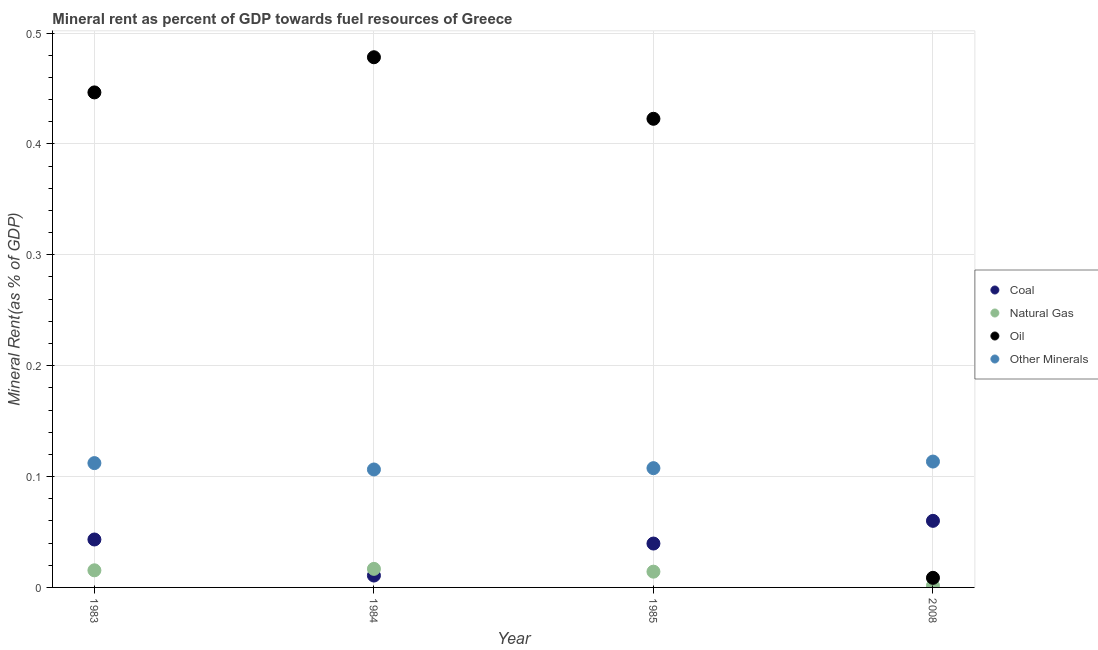What is the  rent of other minerals in 1984?
Provide a short and direct response. 0.11. Across all years, what is the maximum coal rent?
Your response must be concise. 0.06. Across all years, what is the minimum  rent of other minerals?
Offer a terse response. 0.11. In which year was the coal rent minimum?
Offer a terse response. 1984. What is the total oil rent in the graph?
Your answer should be compact. 1.36. What is the difference between the coal rent in 1983 and that in 2008?
Your answer should be compact. -0.02. What is the difference between the  rent of other minerals in 1985 and the natural gas rent in 2008?
Provide a succinct answer. 0.11. What is the average  rent of other minerals per year?
Provide a short and direct response. 0.11. In the year 1985, what is the difference between the oil rent and natural gas rent?
Offer a very short reply. 0.41. In how many years, is the coal rent greater than 0.34 %?
Ensure brevity in your answer.  0. What is the ratio of the  rent of other minerals in 1984 to that in 2008?
Your response must be concise. 0.94. Is the difference between the natural gas rent in 1983 and 2008 greater than the difference between the  rent of other minerals in 1983 and 2008?
Your response must be concise. Yes. What is the difference between the highest and the second highest coal rent?
Keep it short and to the point. 0.02. What is the difference between the highest and the lowest natural gas rent?
Ensure brevity in your answer.  0.02. Is the sum of the natural gas rent in 1984 and 2008 greater than the maximum coal rent across all years?
Give a very brief answer. No. Is it the case that in every year, the sum of the natural gas rent and oil rent is greater than the sum of coal rent and  rent of other minerals?
Your response must be concise. No. Does the natural gas rent monotonically increase over the years?
Your answer should be very brief. No. Is the oil rent strictly greater than the  rent of other minerals over the years?
Offer a terse response. No. Is the natural gas rent strictly less than the coal rent over the years?
Provide a succinct answer. No. How many dotlines are there?
Keep it short and to the point. 4. How many years are there in the graph?
Give a very brief answer. 4. What is the difference between two consecutive major ticks on the Y-axis?
Provide a short and direct response. 0.1. Where does the legend appear in the graph?
Offer a very short reply. Center right. What is the title of the graph?
Your response must be concise. Mineral rent as percent of GDP towards fuel resources of Greece. What is the label or title of the Y-axis?
Provide a short and direct response. Mineral Rent(as % of GDP). What is the Mineral Rent(as % of GDP) in Coal in 1983?
Keep it short and to the point. 0.04. What is the Mineral Rent(as % of GDP) of Natural Gas in 1983?
Your response must be concise. 0.02. What is the Mineral Rent(as % of GDP) in Oil in 1983?
Keep it short and to the point. 0.45. What is the Mineral Rent(as % of GDP) of Other Minerals in 1983?
Ensure brevity in your answer.  0.11. What is the Mineral Rent(as % of GDP) of Coal in 1984?
Ensure brevity in your answer.  0.01. What is the Mineral Rent(as % of GDP) in Natural Gas in 1984?
Your answer should be compact. 0.02. What is the Mineral Rent(as % of GDP) in Oil in 1984?
Provide a short and direct response. 0.48. What is the Mineral Rent(as % of GDP) of Other Minerals in 1984?
Provide a succinct answer. 0.11. What is the Mineral Rent(as % of GDP) of Coal in 1985?
Keep it short and to the point. 0.04. What is the Mineral Rent(as % of GDP) in Natural Gas in 1985?
Make the answer very short. 0.01. What is the Mineral Rent(as % of GDP) in Oil in 1985?
Make the answer very short. 0.42. What is the Mineral Rent(as % of GDP) of Other Minerals in 1985?
Your answer should be very brief. 0.11. What is the Mineral Rent(as % of GDP) of Coal in 2008?
Offer a very short reply. 0.06. What is the Mineral Rent(as % of GDP) in Natural Gas in 2008?
Your answer should be very brief. 0. What is the Mineral Rent(as % of GDP) of Oil in 2008?
Ensure brevity in your answer.  0.01. What is the Mineral Rent(as % of GDP) in Other Minerals in 2008?
Keep it short and to the point. 0.11. Across all years, what is the maximum Mineral Rent(as % of GDP) in Coal?
Offer a terse response. 0.06. Across all years, what is the maximum Mineral Rent(as % of GDP) of Natural Gas?
Offer a terse response. 0.02. Across all years, what is the maximum Mineral Rent(as % of GDP) of Oil?
Your response must be concise. 0.48. Across all years, what is the maximum Mineral Rent(as % of GDP) in Other Minerals?
Ensure brevity in your answer.  0.11. Across all years, what is the minimum Mineral Rent(as % of GDP) in Coal?
Your response must be concise. 0.01. Across all years, what is the minimum Mineral Rent(as % of GDP) of Natural Gas?
Provide a succinct answer. 0. Across all years, what is the minimum Mineral Rent(as % of GDP) in Oil?
Your response must be concise. 0.01. Across all years, what is the minimum Mineral Rent(as % of GDP) of Other Minerals?
Offer a terse response. 0.11. What is the total Mineral Rent(as % of GDP) in Coal in the graph?
Offer a terse response. 0.15. What is the total Mineral Rent(as % of GDP) of Natural Gas in the graph?
Offer a terse response. 0.05. What is the total Mineral Rent(as % of GDP) in Oil in the graph?
Offer a terse response. 1.36. What is the total Mineral Rent(as % of GDP) in Other Minerals in the graph?
Ensure brevity in your answer.  0.44. What is the difference between the Mineral Rent(as % of GDP) of Coal in 1983 and that in 1984?
Your answer should be very brief. 0.03. What is the difference between the Mineral Rent(as % of GDP) in Natural Gas in 1983 and that in 1984?
Your answer should be very brief. -0. What is the difference between the Mineral Rent(as % of GDP) in Oil in 1983 and that in 1984?
Provide a short and direct response. -0.03. What is the difference between the Mineral Rent(as % of GDP) in Other Minerals in 1983 and that in 1984?
Your answer should be very brief. 0.01. What is the difference between the Mineral Rent(as % of GDP) in Coal in 1983 and that in 1985?
Your response must be concise. 0. What is the difference between the Mineral Rent(as % of GDP) of Natural Gas in 1983 and that in 1985?
Your answer should be compact. 0. What is the difference between the Mineral Rent(as % of GDP) in Oil in 1983 and that in 1985?
Provide a succinct answer. 0.02. What is the difference between the Mineral Rent(as % of GDP) of Other Minerals in 1983 and that in 1985?
Your response must be concise. 0. What is the difference between the Mineral Rent(as % of GDP) of Coal in 1983 and that in 2008?
Your response must be concise. -0.02. What is the difference between the Mineral Rent(as % of GDP) of Natural Gas in 1983 and that in 2008?
Give a very brief answer. 0.01. What is the difference between the Mineral Rent(as % of GDP) of Oil in 1983 and that in 2008?
Your response must be concise. 0.44. What is the difference between the Mineral Rent(as % of GDP) of Other Minerals in 1983 and that in 2008?
Give a very brief answer. -0. What is the difference between the Mineral Rent(as % of GDP) in Coal in 1984 and that in 1985?
Provide a succinct answer. -0.03. What is the difference between the Mineral Rent(as % of GDP) in Natural Gas in 1984 and that in 1985?
Offer a very short reply. 0. What is the difference between the Mineral Rent(as % of GDP) of Oil in 1984 and that in 1985?
Your response must be concise. 0.06. What is the difference between the Mineral Rent(as % of GDP) in Other Minerals in 1984 and that in 1985?
Offer a terse response. -0. What is the difference between the Mineral Rent(as % of GDP) of Coal in 1984 and that in 2008?
Offer a terse response. -0.05. What is the difference between the Mineral Rent(as % of GDP) in Natural Gas in 1984 and that in 2008?
Offer a very short reply. 0.02. What is the difference between the Mineral Rent(as % of GDP) of Oil in 1984 and that in 2008?
Your response must be concise. 0.47. What is the difference between the Mineral Rent(as % of GDP) in Other Minerals in 1984 and that in 2008?
Your answer should be compact. -0.01. What is the difference between the Mineral Rent(as % of GDP) of Coal in 1985 and that in 2008?
Make the answer very short. -0.02. What is the difference between the Mineral Rent(as % of GDP) of Natural Gas in 1985 and that in 2008?
Provide a succinct answer. 0.01. What is the difference between the Mineral Rent(as % of GDP) of Oil in 1985 and that in 2008?
Your response must be concise. 0.41. What is the difference between the Mineral Rent(as % of GDP) of Other Minerals in 1985 and that in 2008?
Your answer should be compact. -0.01. What is the difference between the Mineral Rent(as % of GDP) in Coal in 1983 and the Mineral Rent(as % of GDP) in Natural Gas in 1984?
Offer a terse response. 0.03. What is the difference between the Mineral Rent(as % of GDP) of Coal in 1983 and the Mineral Rent(as % of GDP) of Oil in 1984?
Your answer should be compact. -0.43. What is the difference between the Mineral Rent(as % of GDP) of Coal in 1983 and the Mineral Rent(as % of GDP) of Other Minerals in 1984?
Your answer should be compact. -0.06. What is the difference between the Mineral Rent(as % of GDP) in Natural Gas in 1983 and the Mineral Rent(as % of GDP) in Oil in 1984?
Ensure brevity in your answer.  -0.46. What is the difference between the Mineral Rent(as % of GDP) in Natural Gas in 1983 and the Mineral Rent(as % of GDP) in Other Minerals in 1984?
Your answer should be compact. -0.09. What is the difference between the Mineral Rent(as % of GDP) in Oil in 1983 and the Mineral Rent(as % of GDP) in Other Minerals in 1984?
Your answer should be compact. 0.34. What is the difference between the Mineral Rent(as % of GDP) in Coal in 1983 and the Mineral Rent(as % of GDP) in Natural Gas in 1985?
Give a very brief answer. 0.03. What is the difference between the Mineral Rent(as % of GDP) of Coal in 1983 and the Mineral Rent(as % of GDP) of Oil in 1985?
Provide a short and direct response. -0.38. What is the difference between the Mineral Rent(as % of GDP) in Coal in 1983 and the Mineral Rent(as % of GDP) in Other Minerals in 1985?
Ensure brevity in your answer.  -0.06. What is the difference between the Mineral Rent(as % of GDP) of Natural Gas in 1983 and the Mineral Rent(as % of GDP) of Oil in 1985?
Offer a terse response. -0.41. What is the difference between the Mineral Rent(as % of GDP) in Natural Gas in 1983 and the Mineral Rent(as % of GDP) in Other Minerals in 1985?
Your answer should be very brief. -0.09. What is the difference between the Mineral Rent(as % of GDP) in Oil in 1983 and the Mineral Rent(as % of GDP) in Other Minerals in 1985?
Give a very brief answer. 0.34. What is the difference between the Mineral Rent(as % of GDP) of Coal in 1983 and the Mineral Rent(as % of GDP) of Natural Gas in 2008?
Provide a short and direct response. 0.04. What is the difference between the Mineral Rent(as % of GDP) of Coal in 1983 and the Mineral Rent(as % of GDP) of Oil in 2008?
Your response must be concise. 0.03. What is the difference between the Mineral Rent(as % of GDP) in Coal in 1983 and the Mineral Rent(as % of GDP) in Other Minerals in 2008?
Your answer should be compact. -0.07. What is the difference between the Mineral Rent(as % of GDP) in Natural Gas in 1983 and the Mineral Rent(as % of GDP) in Oil in 2008?
Make the answer very short. 0.01. What is the difference between the Mineral Rent(as % of GDP) of Natural Gas in 1983 and the Mineral Rent(as % of GDP) of Other Minerals in 2008?
Keep it short and to the point. -0.1. What is the difference between the Mineral Rent(as % of GDP) in Oil in 1983 and the Mineral Rent(as % of GDP) in Other Minerals in 2008?
Offer a terse response. 0.33. What is the difference between the Mineral Rent(as % of GDP) of Coal in 1984 and the Mineral Rent(as % of GDP) of Natural Gas in 1985?
Keep it short and to the point. -0. What is the difference between the Mineral Rent(as % of GDP) of Coal in 1984 and the Mineral Rent(as % of GDP) of Oil in 1985?
Ensure brevity in your answer.  -0.41. What is the difference between the Mineral Rent(as % of GDP) of Coal in 1984 and the Mineral Rent(as % of GDP) of Other Minerals in 1985?
Provide a succinct answer. -0.1. What is the difference between the Mineral Rent(as % of GDP) of Natural Gas in 1984 and the Mineral Rent(as % of GDP) of Oil in 1985?
Offer a very short reply. -0.41. What is the difference between the Mineral Rent(as % of GDP) of Natural Gas in 1984 and the Mineral Rent(as % of GDP) of Other Minerals in 1985?
Offer a terse response. -0.09. What is the difference between the Mineral Rent(as % of GDP) in Oil in 1984 and the Mineral Rent(as % of GDP) in Other Minerals in 1985?
Keep it short and to the point. 0.37. What is the difference between the Mineral Rent(as % of GDP) in Coal in 1984 and the Mineral Rent(as % of GDP) in Natural Gas in 2008?
Keep it short and to the point. 0.01. What is the difference between the Mineral Rent(as % of GDP) of Coal in 1984 and the Mineral Rent(as % of GDP) of Oil in 2008?
Provide a short and direct response. 0. What is the difference between the Mineral Rent(as % of GDP) in Coal in 1984 and the Mineral Rent(as % of GDP) in Other Minerals in 2008?
Offer a very short reply. -0.1. What is the difference between the Mineral Rent(as % of GDP) in Natural Gas in 1984 and the Mineral Rent(as % of GDP) in Oil in 2008?
Offer a terse response. 0.01. What is the difference between the Mineral Rent(as % of GDP) of Natural Gas in 1984 and the Mineral Rent(as % of GDP) of Other Minerals in 2008?
Give a very brief answer. -0.1. What is the difference between the Mineral Rent(as % of GDP) in Oil in 1984 and the Mineral Rent(as % of GDP) in Other Minerals in 2008?
Offer a very short reply. 0.36. What is the difference between the Mineral Rent(as % of GDP) in Coal in 1985 and the Mineral Rent(as % of GDP) in Natural Gas in 2008?
Keep it short and to the point. 0.04. What is the difference between the Mineral Rent(as % of GDP) of Coal in 1985 and the Mineral Rent(as % of GDP) of Oil in 2008?
Make the answer very short. 0.03. What is the difference between the Mineral Rent(as % of GDP) in Coal in 1985 and the Mineral Rent(as % of GDP) in Other Minerals in 2008?
Your response must be concise. -0.07. What is the difference between the Mineral Rent(as % of GDP) in Natural Gas in 1985 and the Mineral Rent(as % of GDP) in Oil in 2008?
Ensure brevity in your answer.  0.01. What is the difference between the Mineral Rent(as % of GDP) of Natural Gas in 1985 and the Mineral Rent(as % of GDP) of Other Minerals in 2008?
Provide a short and direct response. -0.1. What is the difference between the Mineral Rent(as % of GDP) of Oil in 1985 and the Mineral Rent(as % of GDP) of Other Minerals in 2008?
Offer a very short reply. 0.31. What is the average Mineral Rent(as % of GDP) in Coal per year?
Give a very brief answer. 0.04. What is the average Mineral Rent(as % of GDP) of Natural Gas per year?
Make the answer very short. 0.01. What is the average Mineral Rent(as % of GDP) in Oil per year?
Give a very brief answer. 0.34. What is the average Mineral Rent(as % of GDP) in Other Minerals per year?
Ensure brevity in your answer.  0.11. In the year 1983, what is the difference between the Mineral Rent(as % of GDP) in Coal and Mineral Rent(as % of GDP) in Natural Gas?
Provide a succinct answer. 0.03. In the year 1983, what is the difference between the Mineral Rent(as % of GDP) in Coal and Mineral Rent(as % of GDP) in Oil?
Keep it short and to the point. -0.4. In the year 1983, what is the difference between the Mineral Rent(as % of GDP) of Coal and Mineral Rent(as % of GDP) of Other Minerals?
Keep it short and to the point. -0.07. In the year 1983, what is the difference between the Mineral Rent(as % of GDP) in Natural Gas and Mineral Rent(as % of GDP) in Oil?
Your answer should be compact. -0.43. In the year 1983, what is the difference between the Mineral Rent(as % of GDP) in Natural Gas and Mineral Rent(as % of GDP) in Other Minerals?
Give a very brief answer. -0.1. In the year 1983, what is the difference between the Mineral Rent(as % of GDP) of Oil and Mineral Rent(as % of GDP) of Other Minerals?
Provide a succinct answer. 0.33. In the year 1984, what is the difference between the Mineral Rent(as % of GDP) of Coal and Mineral Rent(as % of GDP) of Natural Gas?
Your response must be concise. -0.01. In the year 1984, what is the difference between the Mineral Rent(as % of GDP) in Coal and Mineral Rent(as % of GDP) in Oil?
Ensure brevity in your answer.  -0.47. In the year 1984, what is the difference between the Mineral Rent(as % of GDP) in Coal and Mineral Rent(as % of GDP) in Other Minerals?
Provide a short and direct response. -0.1. In the year 1984, what is the difference between the Mineral Rent(as % of GDP) of Natural Gas and Mineral Rent(as % of GDP) of Oil?
Provide a succinct answer. -0.46. In the year 1984, what is the difference between the Mineral Rent(as % of GDP) in Natural Gas and Mineral Rent(as % of GDP) in Other Minerals?
Offer a terse response. -0.09. In the year 1984, what is the difference between the Mineral Rent(as % of GDP) of Oil and Mineral Rent(as % of GDP) of Other Minerals?
Make the answer very short. 0.37. In the year 1985, what is the difference between the Mineral Rent(as % of GDP) in Coal and Mineral Rent(as % of GDP) in Natural Gas?
Provide a short and direct response. 0.03. In the year 1985, what is the difference between the Mineral Rent(as % of GDP) of Coal and Mineral Rent(as % of GDP) of Oil?
Ensure brevity in your answer.  -0.38. In the year 1985, what is the difference between the Mineral Rent(as % of GDP) of Coal and Mineral Rent(as % of GDP) of Other Minerals?
Your answer should be compact. -0.07. In the year 1985, what is the difference between the Mineral Rent(as % of GDP) of Natural Gas and Mineral Rent(as % of GDP) of Oil?
Provide a short and direct response. -0.41. In the year 1985, what is the difference between the Mineral Rent(as % of GDP) of Natural Gas and Mineral Rent(as % of GDP) of Other Minerals?
Offer a very short reply. -0.09. In the year 1985, what is the difference between the Mineral Rent(as % of GDP) of Oil and Mineral Rent(as % of GDP) of Other Minerals?
Give a very brief answer. 0.32. In the year 2008, what is the difference between the Mineral Rent(as % of GDP) in Coal and Mineral Rent(as % of GDP) in Natural Gas?
Provide a succinct answer. 0.06. In the year 2008, what is the difference between the Mineral Rent(as % of GDP) in Coal and Mineral Rent(as % of GDP) in Oil?
Give a very brief answer. 0.05. In the year 2008, what is the difference between the Mineral Rent(as % of GDP) in Coal and Mineral Rent(as % of GDP) in Other Minerals?
Your answer should be very brief. -0.05. In the year 2008, what is the difference between the Mineral Rent(as % of GDP) of Natural Gas and Mineral Rent(as % of GDP) of Oil?
Give a very brief answer. -0.01. In the year 2008, what is the difference between the Mineral Rent(as % of GDP) in Natural Gas and Mineral Rent(as % of GDP) in Other Minerals?
Your response must be concise. -0.11. In the year 2008, what is the difference between the Mineral Rent(as % of GDP) in Oil and Mineral Rent(as % of GDP) in Other Minerals?
Provide a short and direct response. -0.1. What is the ratio of the Mineral Rent(as % of GDP) of Coal in 1983 to that in 1984?
Your answer should be very brief. 4.03. What is the ratio of the Mineral Rent(as % of GDP) in Natural Gas in 1983 to that in 1984?
Provide a succinct answer. 0.92. What is the ratio of the Mineral Rent(as % of GDP) of Oil in 1983 to that in 1984?
Keep it short and to the point. 0.93. What is the ratio of the Mineral Rent(as % of GDP) of Other Minerals in 1983 to that in 1984?
Offer a very short reply. 1.05. What is the ratio of the Mineral Rent(as % of GDP) in Coal in 1983 to that in 1985?
Your answer should be very brief. 1.09. What is the ratio of the Mineral Rent(as % of GDP) in Natural Gas in 1983 to that in 1985?
Provide a succinct answer. 1.09. What is the ratio of the Mineral Rent(as % of GDP) in Oil in 1983 to that in 1985?
Give a very brief answer. 1.06. What is the ratio of the Mineral Rent(as % of GDP) in Other Minerals in 1983 to that in 1985?
Ensure brevity in your answer.  1.04. What is the ratio of the Mineral Rent(as % of GDP) of Coal in 1983 to that in 2008?
Your response must be concise. 0.72. What is the ratio of the Mineral Rent(as % of GDP) in Natural Gas in 1983 to that in 2008?
Offer a terse response. 9.75. What is the ratio of the Mineral Rent(as % of GDP) of Oil in 1983 to that in 2008?
Your response must be concise. 51.59. What is the ratio of the Mineral Rent(as % of GDP) in Other Minerals in 1983 to that in 2008?
Your answer should be compact. 0.99. What is the ratio of the Mineral Rent(as % of GDP) in Coal in 1984 to that in 1985?
Ensure brevity in your answer.  0.27. What is the ratio of the Mineral Rent(as % of GDP) of Natural Gas in 1984 to that in 1985?
Provide a short and direct response. 1.18. What is the ratio of the Mineral Rent(as % of GDP) of Oil in 1984 to that in 1985?
Make the answer very short. 1.13. What is the ratio of the Mineral Rent(as % of GDP) of Other Minerals in 1984 to that in 1985?
Keep it short and to the point. 0.99. What is the ratio of the Mineral Rent(as % of GDP) of Coal in 1984 to that in 2008?
Ensure brevity in your answer.  0.18. What is the ratio of the Mineral Rent(as % of GDP) in Natural Gas in 1984 to that in 2008?
Your response must be concise. 10.57. What is the ratio of the Mineral Rent(as % of GDP) of Oil in 1984 to that in 2008?
Provide a succinct answer. 55.26. What is the ratio of the Mineral Rent(as % of GDP) of Other Minerals in 1984 to that in 2008?
Offer a very short reply. 0.94. What is the ratio of the Mineral Rent(as % of GDP) in Coal in 1985 to that in 2008?
Provide a short and direct response. 0.66. What is the ratio of the Mineral Rent(as % of GDP) of Natural Gas in 1985 to that in 2008?
Provide a short and direct response. 8.97. What is the ratio of the Mineral Rent(as % of GDP) of Oil in 1985 to that in 2008?
Your answer should be very brief. 48.84. What is the ratio of the Mineral Rent(as % of GDP) in Other Minerals in 1985 to that in 2008?
Give a very brief answer. 0.95. What is the difference between the highest and the second highest Mineral Rent(as % of GDP) of Coal?
Your answer should be compact. 0.02. What is the difference between the highest and the second highest Mineral Rent(as % of GDP) of Natural Gas?
Offer a terse response. 0. What is the difference between the highest and the second highest Mineral Rent(as % of GDP) of Oil?
Provide a succinct answer. 0.03. What is the difference between the highest and the second highest Mineral Rent(as % of GDP) of Other Minerals?
Keep it short and to the point. 0. What is the difference between the highest and the lowest Mineral Rent(as % of GDP) of Coal?
Offer a terse response. 0.05. What is the difference between the highest and the lowest Mineral Rent(as % of GDP) in Natural Gas?
Your answer should be compact. 0.02. What is the difference between the highest and the lowest Mineral Rent(as % of GDP) in Oil?
Your answer should be very brief. 0.47. What is the difference between the highest and the lowest Mineral Rent(as % of GDP) in Other Minerals?
Provide a succinct answer. 0.01. 